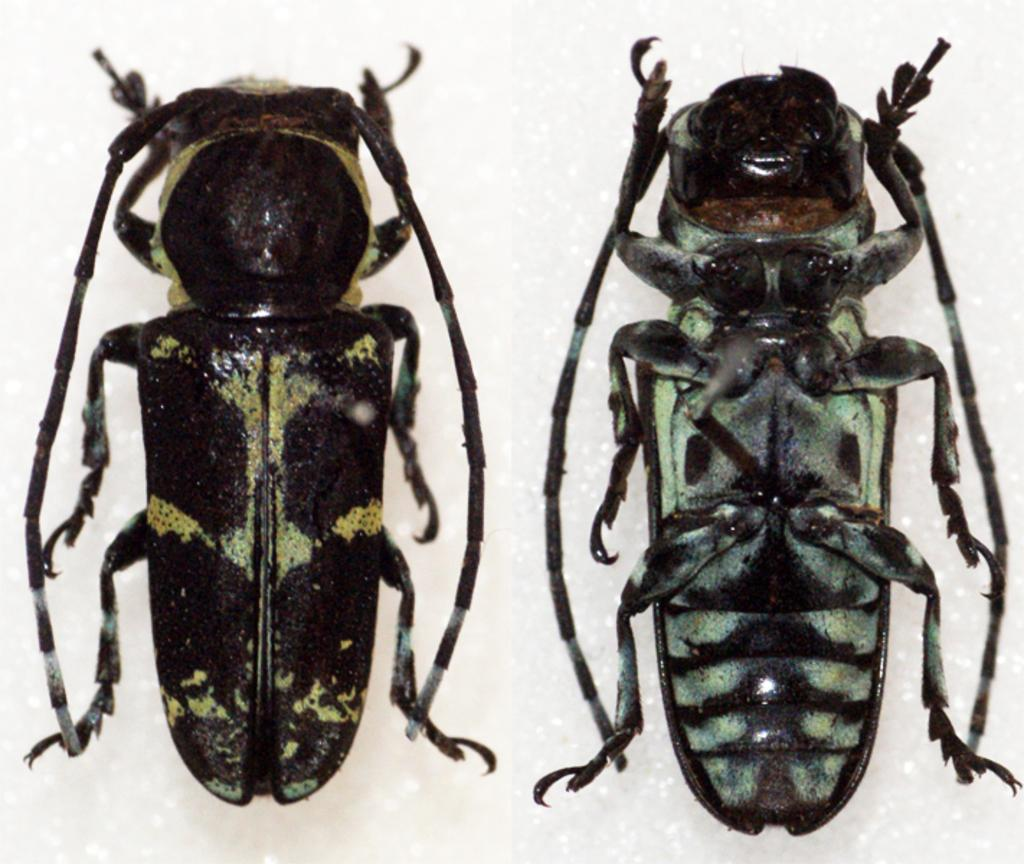How many insects are present in the image? There are two insects in the image. What colors can be seen on the insects? The insects are black and green in color. What is the color of the background in the image? The background of the image is white. What type of coat is the insect wearing in the image? There are no insects wearing coats in the image; they are not dressed in human clothing. 